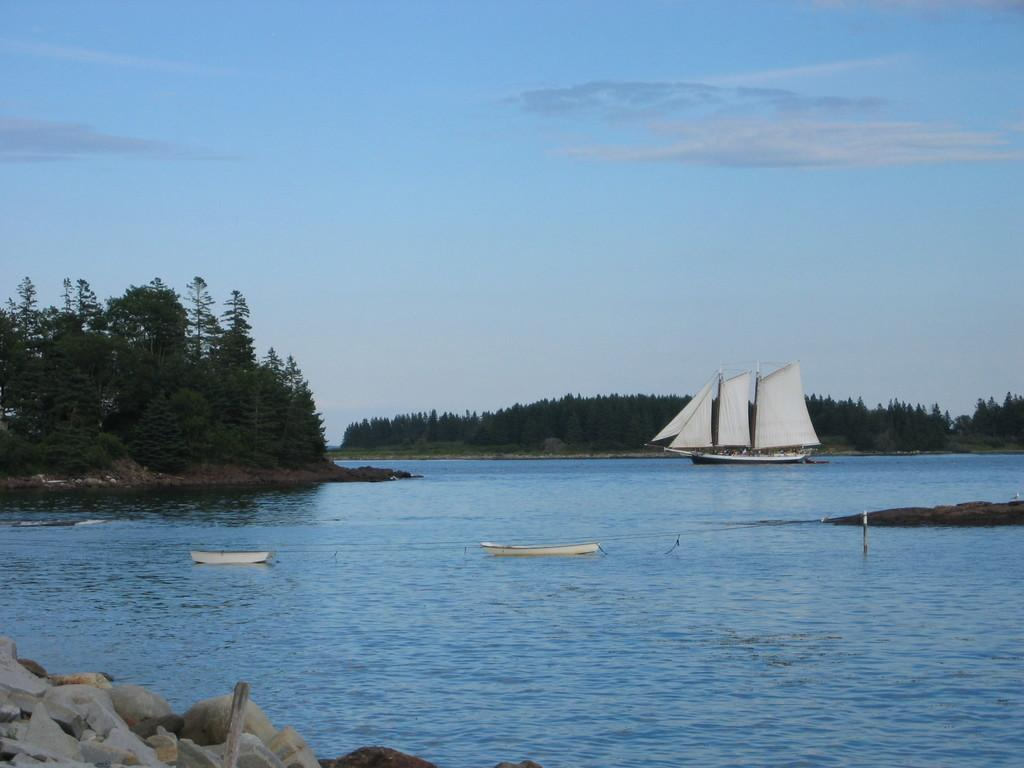What body of water is present in the image? There is a river in the image. What is happening on the river? There are boats sailing on the river. What type of vegetation is on the left side of the image? There are trees on the left side of the image. What is the condition of the sky in the image? The sky is clear in the image. What type of sponge is being used to clean the boats in the image? There is no sponge present in the image, and no boats are being cleaned. 